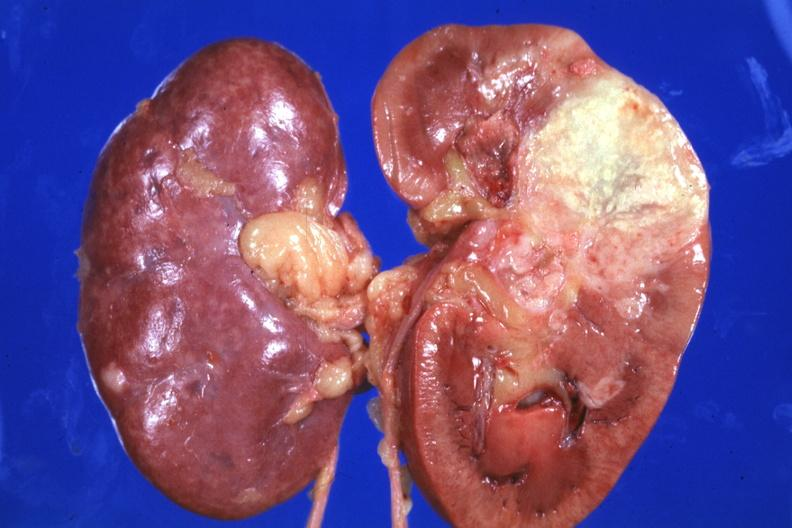s serous cyst present?
Answer the question using a single word or phrase. No 